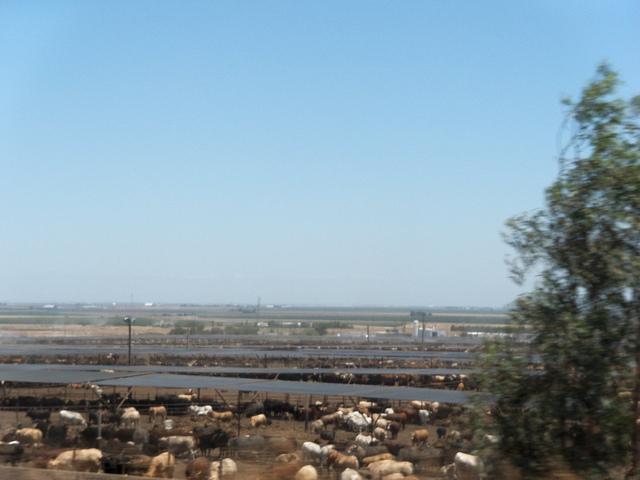Are there tents?
Short answer required. No. What is on the ground?
Write a very short answer. Cows. How many cows are there?
Answer briefly. 30. Where are all the sheep going?
Answer briefly. To eat. What is grazing on the land?
Concise answer only. Cows. What color is the landscape?
Be succinct. Brown. 